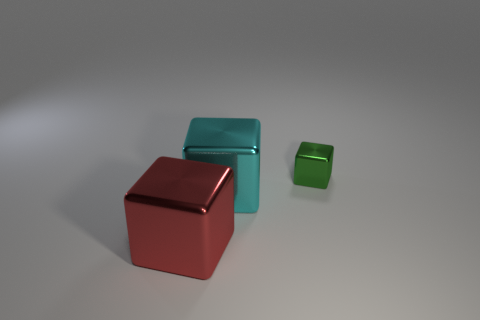There is a red thing that is the same material as the large cyan cube; what shape is it?
Provide a succinct answer. Cube. How big is the shiny block that is on the right side of the large metallic thing behind the large red object?
Your response must be concise. Small. Are there any objects that have the same color as the small cube?
Provide a short and direct response. No. Are there an equal number of big cyan things in front of the tiny object and shiny blocks?
Offer a very short reply. No. What number of small shiny things are there?
Give a very brief answer. 1. What is the shape of the metallic thing that is on the right side of the big red metal cube and to the left of the green block?
Provide a short and direct response. Cube. There is a big shiny object that is left of the large cyan thing; does it have the same color as the large metallic thing behind the red block?
Your answer should be compact. No. Are there any small green cubes made of the same material as the green object?
Make the answer very short. No. Are there an equal number of cyan blocks that are left of the cyan metallic cube and red shiny things to the left of the large red cube?
Your answer should be compact. Yes. What size is the metallic cube to the right of the big cyan thing?
Provide a succinct answer. Small. 